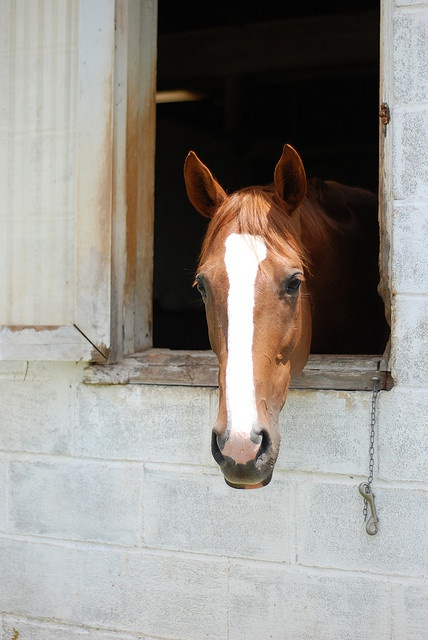Describe the objects in this image and their specific colors. I can see a horse in darkgray, black, white, maroon, and salmon tones in this image. 